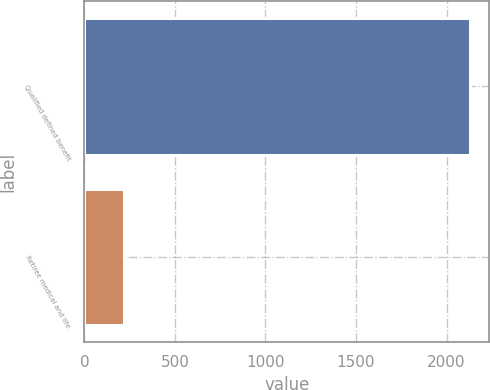Convert chart to OTSL. <chart><loc_0><loc_0><loc_500><loc_500><bar_chart><fcel>Qualified defined benefit<fcel>Retiree medical and life<nl><fcel>2130<fcel>220<nl></chart> 